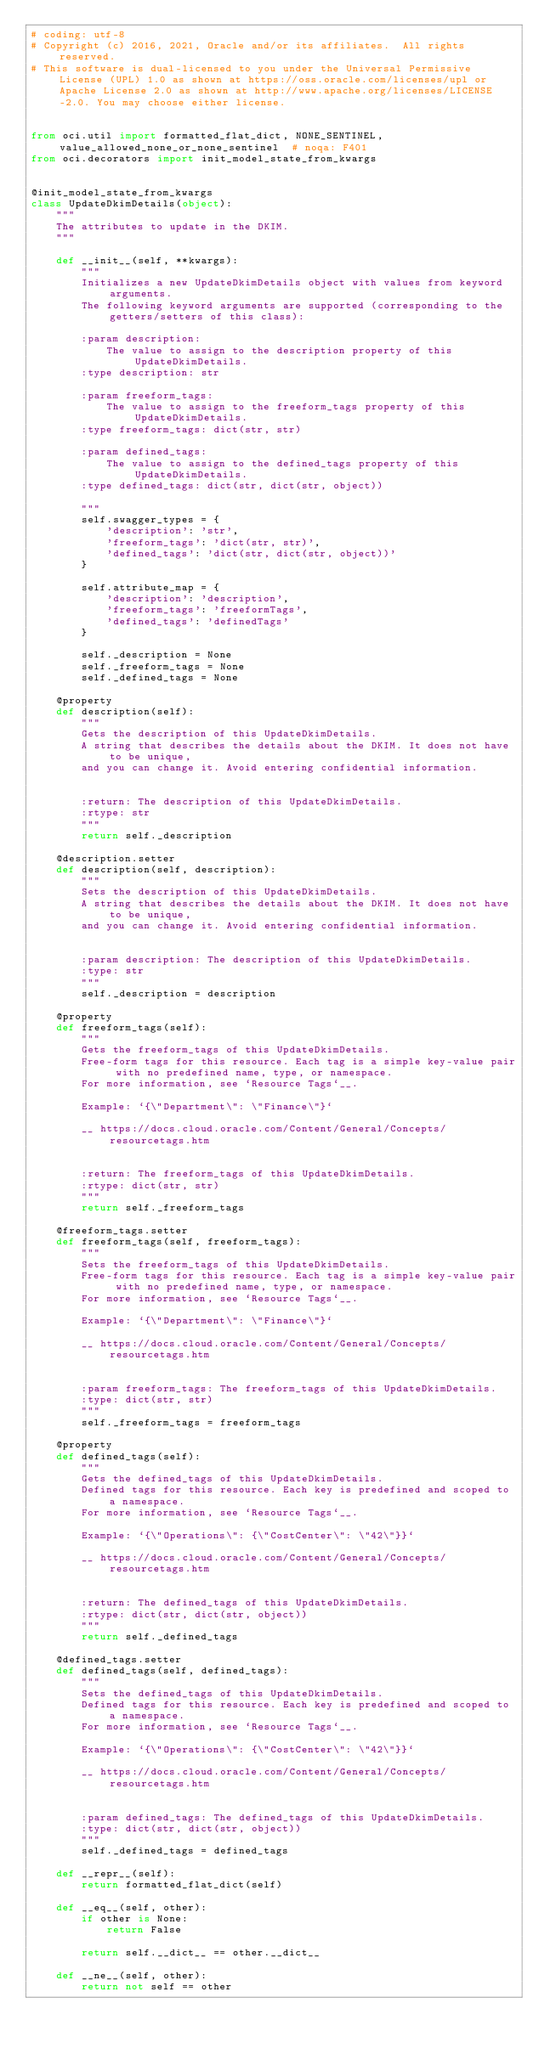Convert code to text. <code><loc_0><loc_0><loc_500><loc_500><_Python_># coding: utf-8
# Copyright (c) 2016, 2021, Oracle and/or its affiliates.  All rights reserved.
# This software is dual-licensed to you under the Universal Permissive License (UPL) 1.0 as shown at https://oss.oracle.com/licenses/upl or Apache License 2.0 as shown at http://www.apache.org/licenses/LICENSE-2.0. You may choose either license.


from oci.util import formatted_flat_dict, NONE_SENTINEL, value_allowed_none_or_none_sentinel  # noqa: F401
from oci.decorators import init_model_state_from_kwargs


@init_model_state_from_kwargs
class UpdateDkimDetails(object):
    """
    The attributes to update in the DKIM.
    """

    def __init__(self, **kwargs):
        """
        Initializes a new UpdateDkimDetails object with values from keyword arguments.
        The following keyword arguments are supported (corresponding to the getters/setters of this class):

        :param description:
            The value to assign to the description property of this UpdateDkimDetails.
        :type description: str

        :param freeform_tags:
            The value to assign to the freeform_tags property of this UpdateDkimDetails.
        :type freeform_tags: dict(str, str)

        :param defined_tags:
            The value to assign to the defined_tags property of this UpdateDkimDetails.
        :type defined_tags: dict(str, dict(str, object))

        """
        self.swagger_types = {
            'description': 'str',
            'freeform_tags': 'dict(str, str)',
            'defined_tags': 'dict(str, dict(str, object))'
        }

        self.attribute_map = {
            'description': 'description',
            'freeform_tags': 'freeformTags',
            'defined_tags': 'definedTags'
        }

        self._description = None
        self._freeform_tags = None
        self._defined_tags = None

    @property
    def description(self):
        """
        Gets the description of this UpdateDkimDetails.
        A string that describes the details about the DKIM. It does not have to be unique,
        and you can change it. Avoid entering confidential information.


        :return: The description of this UpdateDkimDetails.
        :rtype: str
        """
        return self._description

    @description.setter
    def description(self, description):
        """
        Sets the description of this UpdateDkimDetails.
        A string that describes the details about the DKIM. It does not have to be unique,
        and you can change it. Avoid entering confidential information.


        :param description: The description of this UpdateDkimDetails.
        :type: str
        """
        self._description = description

    @property
    def freeform_tags(self):
        """
        Gets the freeform_tags of this UpdateDkimDetails.
        Free-form tags for this resource. Each tag is a simple key-value pair with no predefined name, type, or namespace.
        For more information, see `Resource Tags`__.

        Example: `{\"Department\": \"Finance\"}`

        __ https://docs.cloud.oracle.com/Content/General/Concepts/resourcetags.htm


        :return: The freeform_tags of this UpdateDkimDetails.
        :rtype: dict(str, str)
        """
        return self._freeform_tags

    @freeform_tags.setter
    def freeform_tags(self, freeform_tags):
        """
        Sets the freeform_tags of this UpdateDkimDetails.
        Free-form tags for this resource. Each tag is a simple key-value pair with no predefined name, type, or namespace.
        For more information, see `Resource Tags`__.

        Example: `{\"Department\": \"Finance\"}`

        __ https://docs.cloud.oracle.com/Content/General/Concepts/resourcetags.htm


        :param freeform_tags: The freeform_tags of this UpdateDkimDetails.
        :type: dict(str, str)
        """
        self._freeform_tags = freeform_tags

    @property
    def defined_tags(self):
        """
        Gets the defined_tags of this UpdateDkimDetails.
        Defined tags for this resource. Each key is predefined and scoped to a namespace.
        For more information, see `Resource Tags`__.

        Example: `{\"Operations\": {\"CostCenter\": \"42\"}}`

        __ https://docs.cloud.oracle.com/Content/General/Concepts/resourcetags.htm


        :return: The defined_tags of this UpdateDkimDetails.
        :rtype: dict(str, dict(str, object))
        """
        return self._defined_tags

    @defined_tags.setter
    def defined_tags(self, defined_tags):
        """
        Sets the defined_tags of this UpdateDkimDetails.
        Defined tags for this resource. Each key is predefined and scoped to a namespace.
        For more information, see `Resource Tags`__.

        Example: `{\"Operations\": {\"CostCenter\": \"42\"}}`

        __ https://docs.cloud.oracle.com/Content/General/Concepts/resourcetags.htm


        :param defined_tags: The defined_tags of this UpdateDkimDetails.
        :type: dict(str, dict(str, object))
        """
        self._defined_tags = defined_tags

    def __repr__(self):
        return formatted_flat_dict(self)

    def __eq__(self, other):
        if other is None:
            return False

        return self.__dict__ == other.__dict__

    def __ne__(self, other):
        return not self == other
</code> 